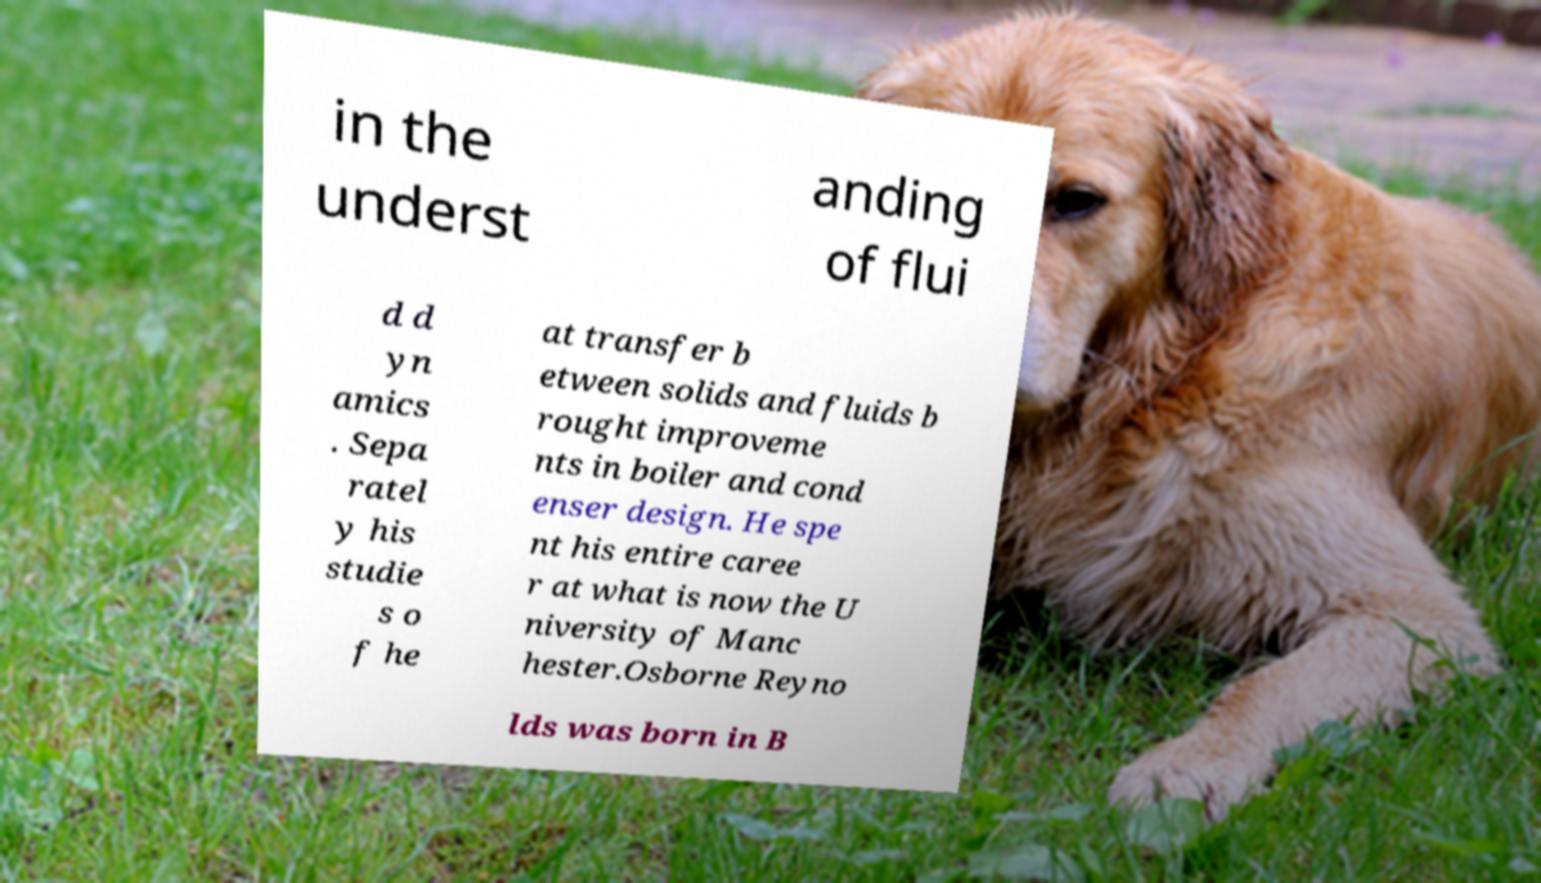Can you read and provide the text displayed in the image?This photo seems to have some interesting text. Can you extract and type it out for me? in the underst anding of flui d d yn amics . Sepa ratel y his studie s o f he at transfer b etween solids and fluids b rought improveme nts in boiler and cond enser design. He spe nt his entire caree r at what is now the U niversity of Manc hester.Osborne Reyno lds was born in B 